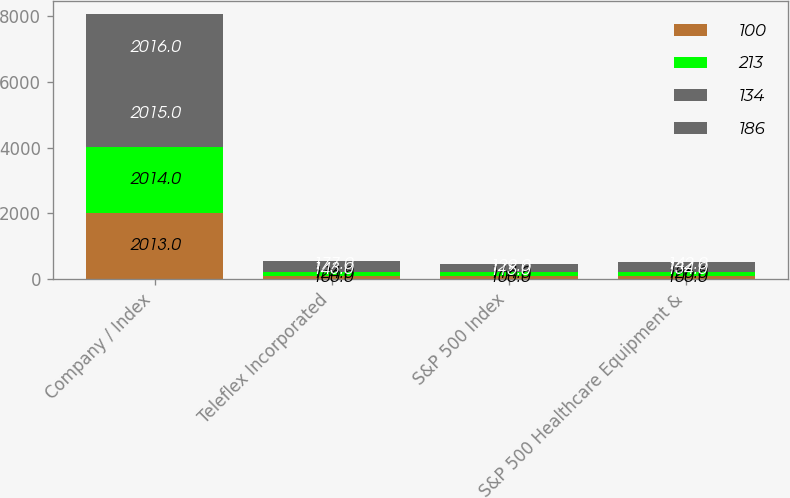Convert chart to OTSL. <chart><loc_0><loc_0><loc_500><loc_500><stacked_bar_chart><ecel><fcel>Company / Index<fcel>Teleflex Incorporated<fcel>S&P 500 Index<fcel>S&P 500 Healthcare Equipment &<nl><fcel>100<fcel>2013<fcel>100<fcel>100<fcel>100<nl><fcel>213<fcel>2014<fcel>124<fcel>114<fcel>126<nl><fcel>134<fcel>2015<fcel>143<fcel>115<fcel>134<nl><fcel>186<fcel>2016<fcel>177<fcel>129<fcel>142<nl></chart> 